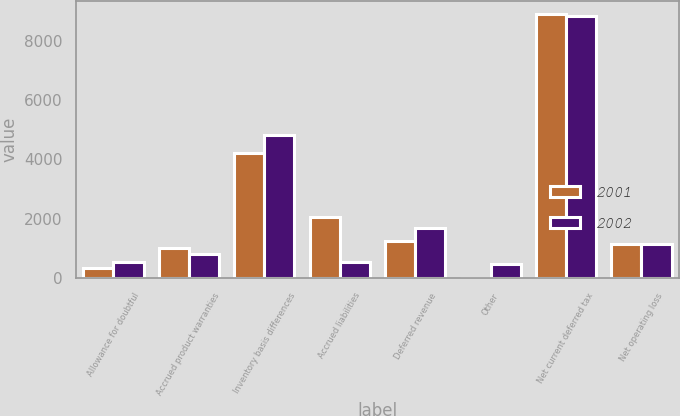Convert chart. <chart><loc_0><loc_0><loc_500><loc_500><stacked_bar_chart><ecel><fcel>Allowance for doubtful<fcel>Accrued product warranties<fcel>Inventory basis differences<fcel>Accrued liabilities<fcel>Deferred revenue<fcel>Other<fcel>Net current deferred tax<fcel>Net operating loss<nl><fcel>2001<fcel>339<fcel>1017<fcel>4220<fcel>2052<fcel>1249<fcel>10<fcel>8887<fcel>1133<nl><fcel>2002<fcel>527<fcel>801<fcel>4811<fcel>538<fcel>1699<fcel>458<fcel>8834<fcel>1133<nl></chart> 